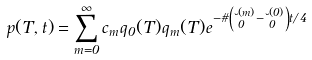<formula> <loc_0><loc_0><loc_500><loc_500>p ( T , t ) = \sum _ { m = 0 } ^ { \infty } c _ { m } q _ { 0 } ( T ) q _ { m } ( T ) e ^ { - \vartheta \left ( \lambda _ { 0 } ^ { ( m ) } - \lambda _ { 0 } ^ { ( 0 ) } \right ) t / 4 }</formula> 